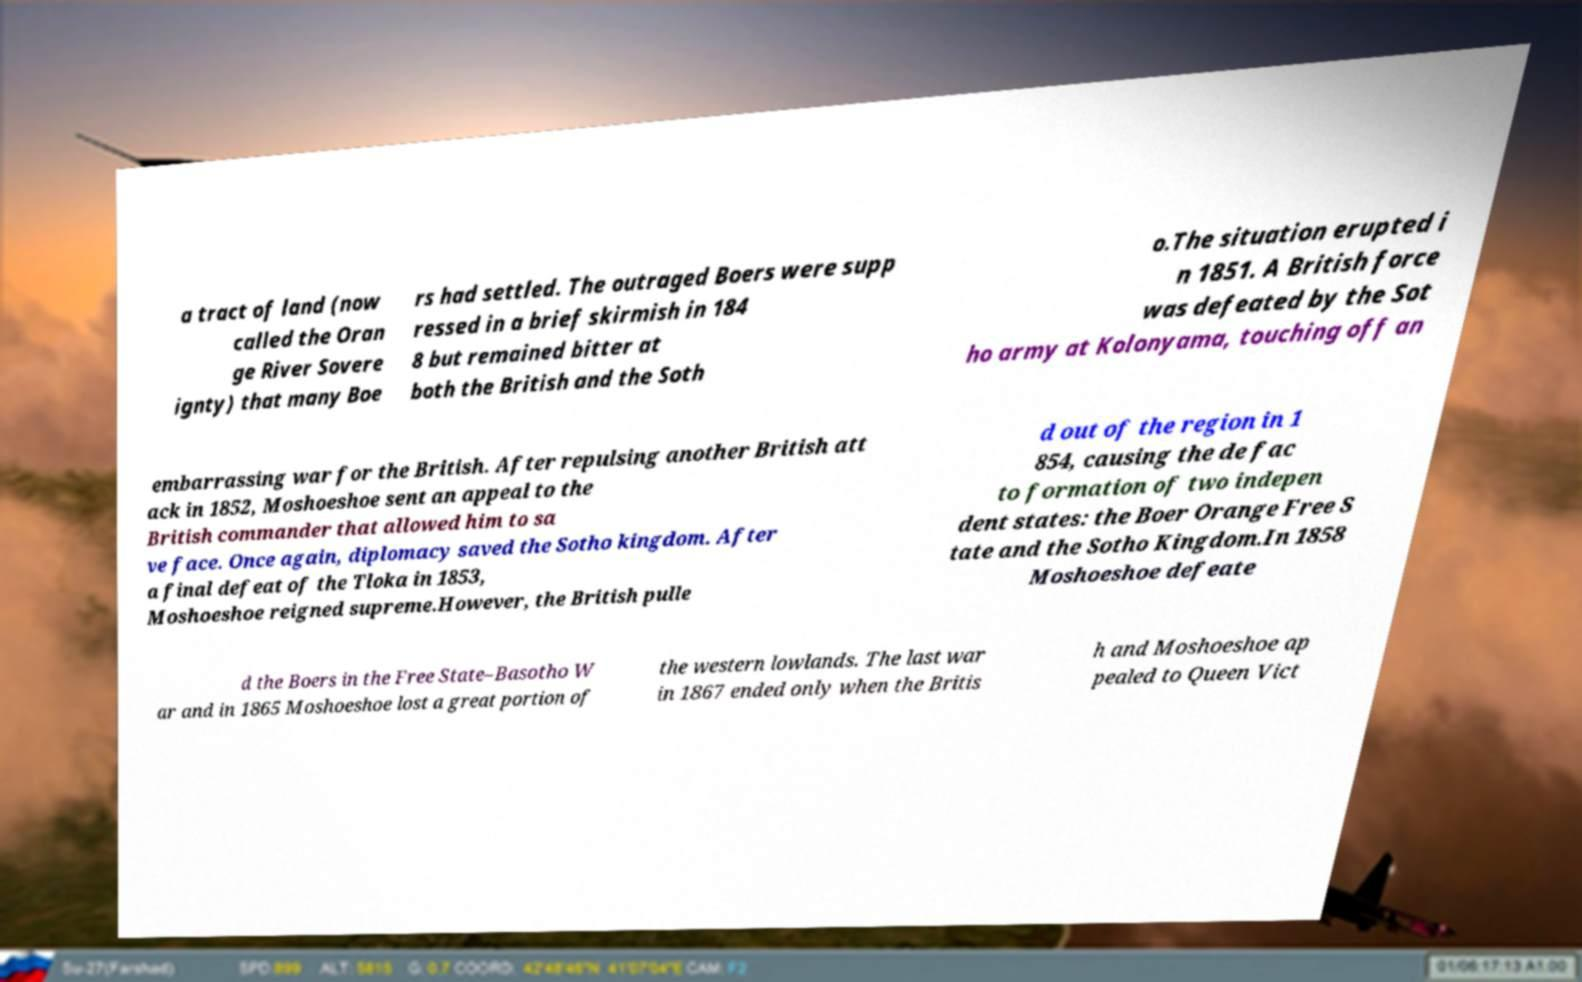What messages or text are displayed in this image? I need them in a readable, typed format. a tract of land (now called the Oran ge River Sovere ignty) that many Boe rs had settled. The outraged Boers were supp ressed in a brief skirmish in 184 8 but remained bitter at both the British and the Soth o.The situation erupted i n 1851. A British force was defeated by the Sot ho army at Kolonyama, touching off an embarrassing war for the British. After repulsing another British att ack in 1852, Moshoeshoe sent an appeal to the British commander that allowed him to sa ve face. Once again, diplomacy saved the Sotho kingdom. After a final defeat of the Tloka in 1853, Moshoeshoe reigned supreme.However, the British pulle d out of the region in 1 854, causing the de fac to formation of two indepen dent states: the Boer Orange Free S tate and the Sotho Kingdom.In 1858 Moshoeshoe defeate d the Boers in the Free State–Basotho W ar and in 1865 Moshoeshoe lost a great portion of the western lowlands. The last war in 1867 ended only when the Britis h and Moshoeshoe ap pealed to Queen Vict 